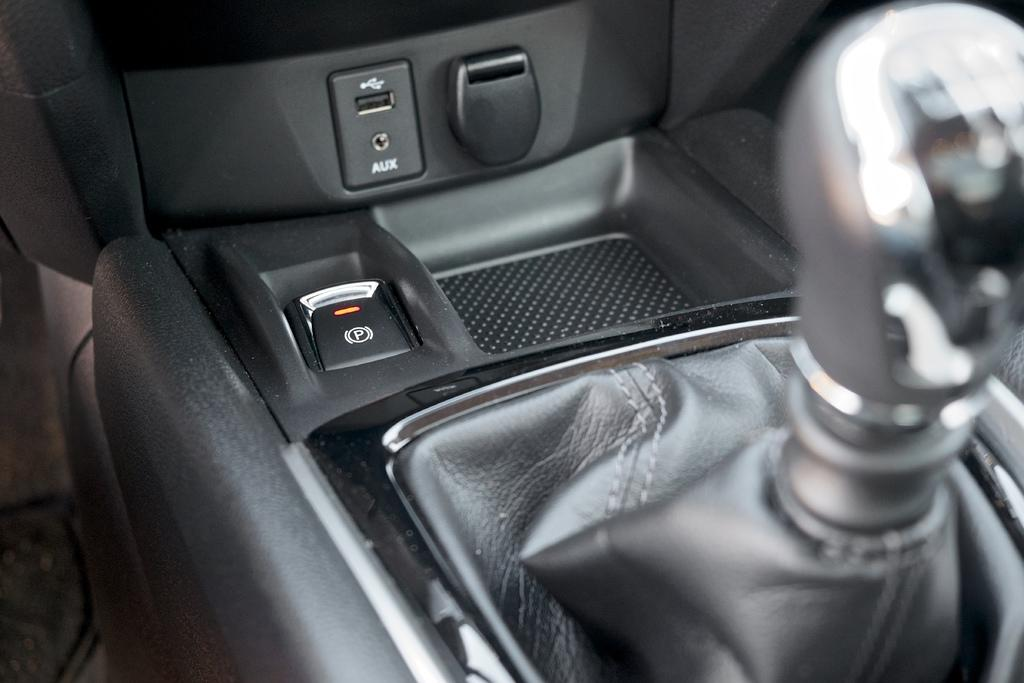What type of setting is depicted in the image? The image shows an inside view of a car. What specific feature can be seen on the right side of the car? There is a gear rod on the right side of the car. What type of jeans is the chair wearing in the image? There is no chair or jeans present in the image; it shows an inside view of a car with a gear rod on the right side. 